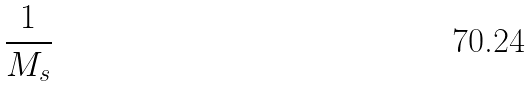<formula> <loc_0><loc_0><loc_500><loc_500>\frac { 1 } { M _ { s } }</formula> 